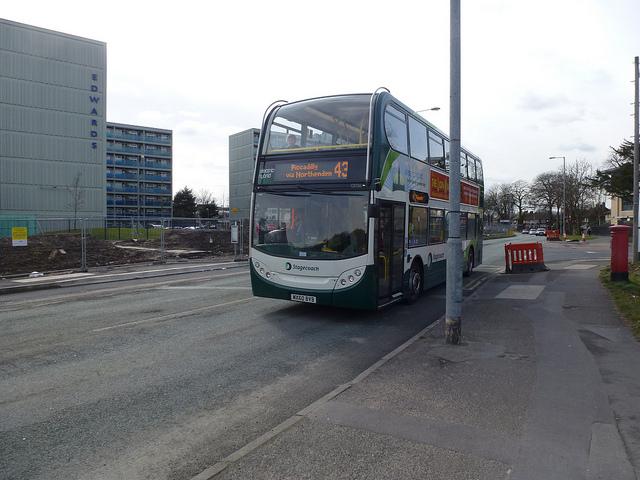Is the bus moving?
Be succinct. No. Does this bus have a known destination?
Be succinct. Yes. Is the road around the bus full of cars?
Short answer required. No. Does it appear to be early morning here?
Answer briefly. Yes. What is the Bus Number?
Answer briefly. 43. What bus number is approaching?
Be succinct. 43. What color is the bus going down the street?
Give a very brief answer. White. Where is the bus parked?
Write a very short answer. Street. Does the bus have it's headlights on?
Keep it brief. No. 